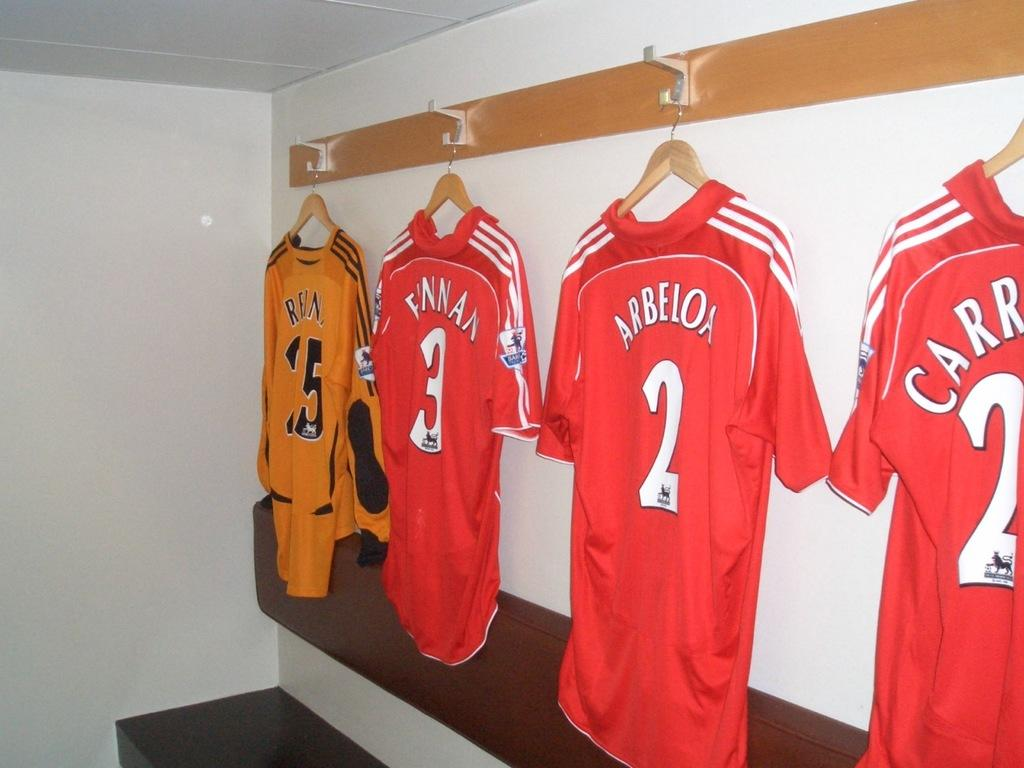<image>
Summarize the visual content of the image. A jersey depicting the name Arbeloa hangs with 3 other jerseys. 